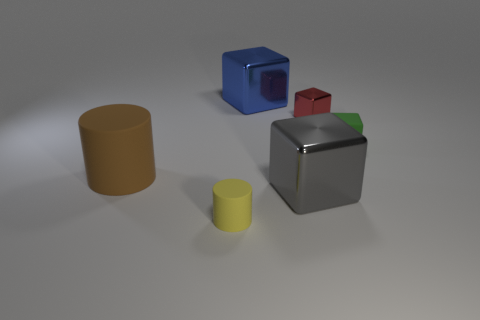Does the tiny yellow cylinder have the same material as the big gray block?
Offer a terse response. No. Are there any cylinders that are on the left side of the small thing in front of the thing on the left side of the yellow cylinder?
Ensure brevity in your answer.  Yes. Is the number of blue shiny things less than the number of big yellow metal cylinders?
Give a very brief answer. No. Is the material of the large cube that is behind the small green thing the same as the small object in front of the small green block?
Your response must be concise. No. Is the number of tiny metallic cubes on the right side of the big blue object less than the number of big brown shiny balls?
Offer a terse response. No. How many small green rubber objects are in front of the metal object in front of the green cube?
Offer a terse response. 0. There is a thing that is both in front of the brown object and left of the blue metallic thing; what is its size?
Provide a short and direct response. Small. Is the material of the small red thing the same as the big cube that is in front of the blue shiny object?
Provide a succinct answer. Yes. Is the number of big brown rubber objects that are behind the green matte cube less than the number of big metallic blocks that are on the left side of the large gray shiny block?
Offer a terse response. Yes. There is a tiny thing in front of the green block; what is its material?
Keep it short and to the point. Rubber. 